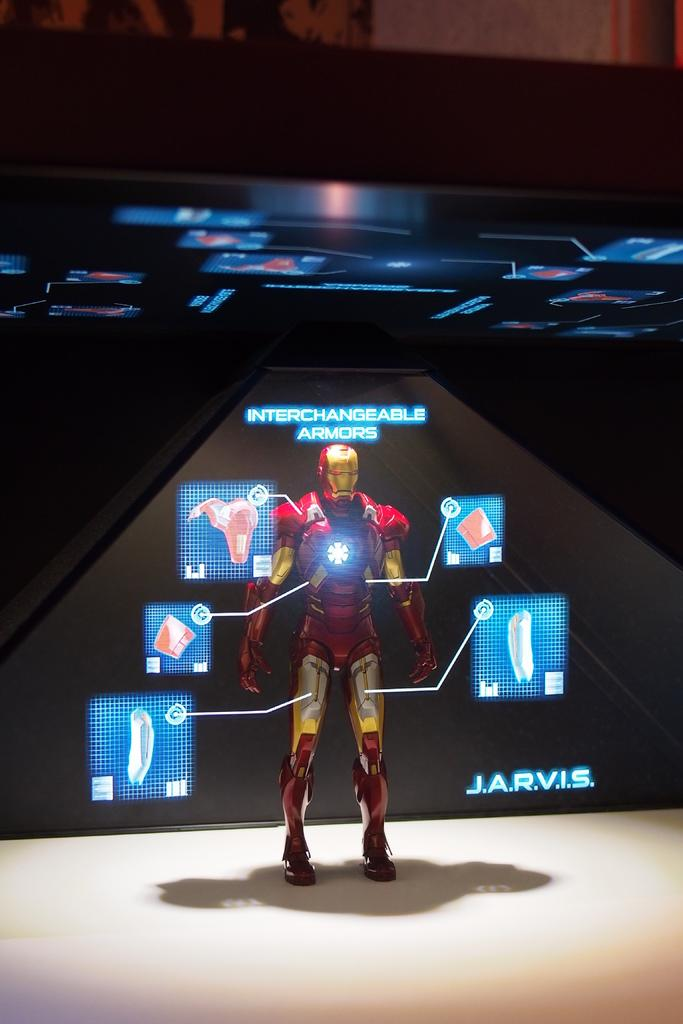<image>
Summarize the visual content of the image. a character that the word jarvis next to him 